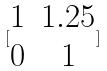<formula> <loc_0><loc_0><loc_500><loc_500>[ \begin{matrix} 1 & 1 . 2 5 \\ 0 & 1 \end{matrix} ]</formula> 